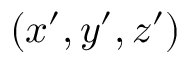Convert formula to latex. <formula><loc_0><loc_0><loc_500><loc_500>( x ^ { \prime } , y ^ { \prime } , z ^ { \prime } )</formula> 